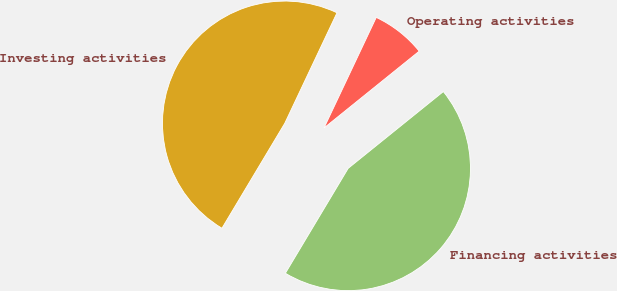Convert chart. <chart><loc_0><loc_0><loc_500><loc_500><pie_chart><fcel>Operating activities<fcel>Investing activities<fcel>Financing activities<nl><fcel>7.17%<fcel>48.44%<fcel>44.39%<nl></chart> 